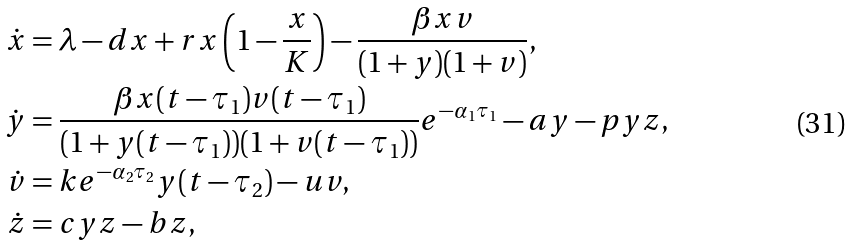<formula> <loc_0><loc_0><loc_500><loc_500>\dot { x } & = \lambda - d x + r x \left ( 1 - \frac { x } { K } \right ) - \frac { \beta x v } { ( 1 + y ) ( 1 + v ) } , \\ \dot { y } & = \frac { \beta x ( t - \tau _ { 1 } ) v ( t - \tau _ { 1 } ) } { ( 1 + y ( t - \tau _ { 1 } ) ) ( 1 + v ( t - \tau _ { 1 } ) ) } e ^ { - \alpha _ { 1 } \tau _ { 1 } } - a y - p y z , \\ \dot { v } & = k e ^ { - \alpha _ { 2 } \tau _ { 2 } } y ( t - \tau _ { 2 } ) - u v , \\ \dot { z } & = c y z - b z ,</formula> 